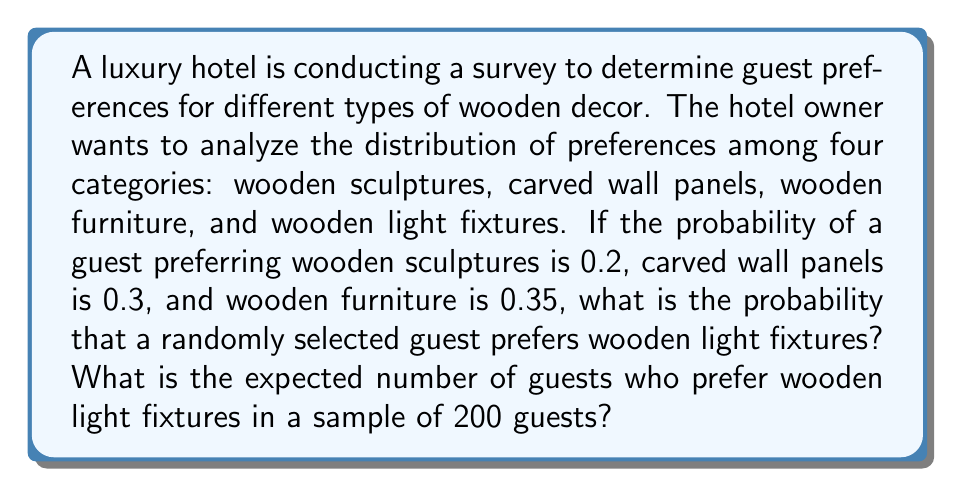What is the answer to this math problem? Let's approach this problem step-by-step:

1. First, we need to determine the probability of a guest preferring wooden light fixtures. We can do this using the law of total probability:

   $P(\text{sculptures}) + P(\text{panels}) + P(\text{furniture}) + P(\text{light fixtures}) = 1$

   $0.2 + 0.3 + 0.35 + P(\text{light fixtures}) = 1$

   $0.85 + P(\text{light fixtures}) = 1$

   $P(\text{light fixtures}) = 1 - 0.85 = 0.15$

2. Now that we have the probability of a guest preferring wooden light fixtures (0.15), we can calculate the expected number of guests who prefer wooden light fixtures in a sample of 200 guests.

3. The number of guests preferring wooden light fixtures follows a binomial distribution with parameters $n = 200$ (number of guests) and $p = 0.15$ (probability of preferring light fixtures).

4. The expected value of a binomial distribution is given by $E(X) = np$, where $n$ is the number of trials and $p$ is the probability of success.

5. Therefore, the expected number of guests preferring wooden light fixtures is:

   $E(X) = np = 200 \cdot 0.15 = 30$
Answer: The probability that a randomly selected guest prefers wooden light fixtures is 0.15.
The expected number of guests who prefer wooden light fixtures in a sample of 200 guests is 30. 